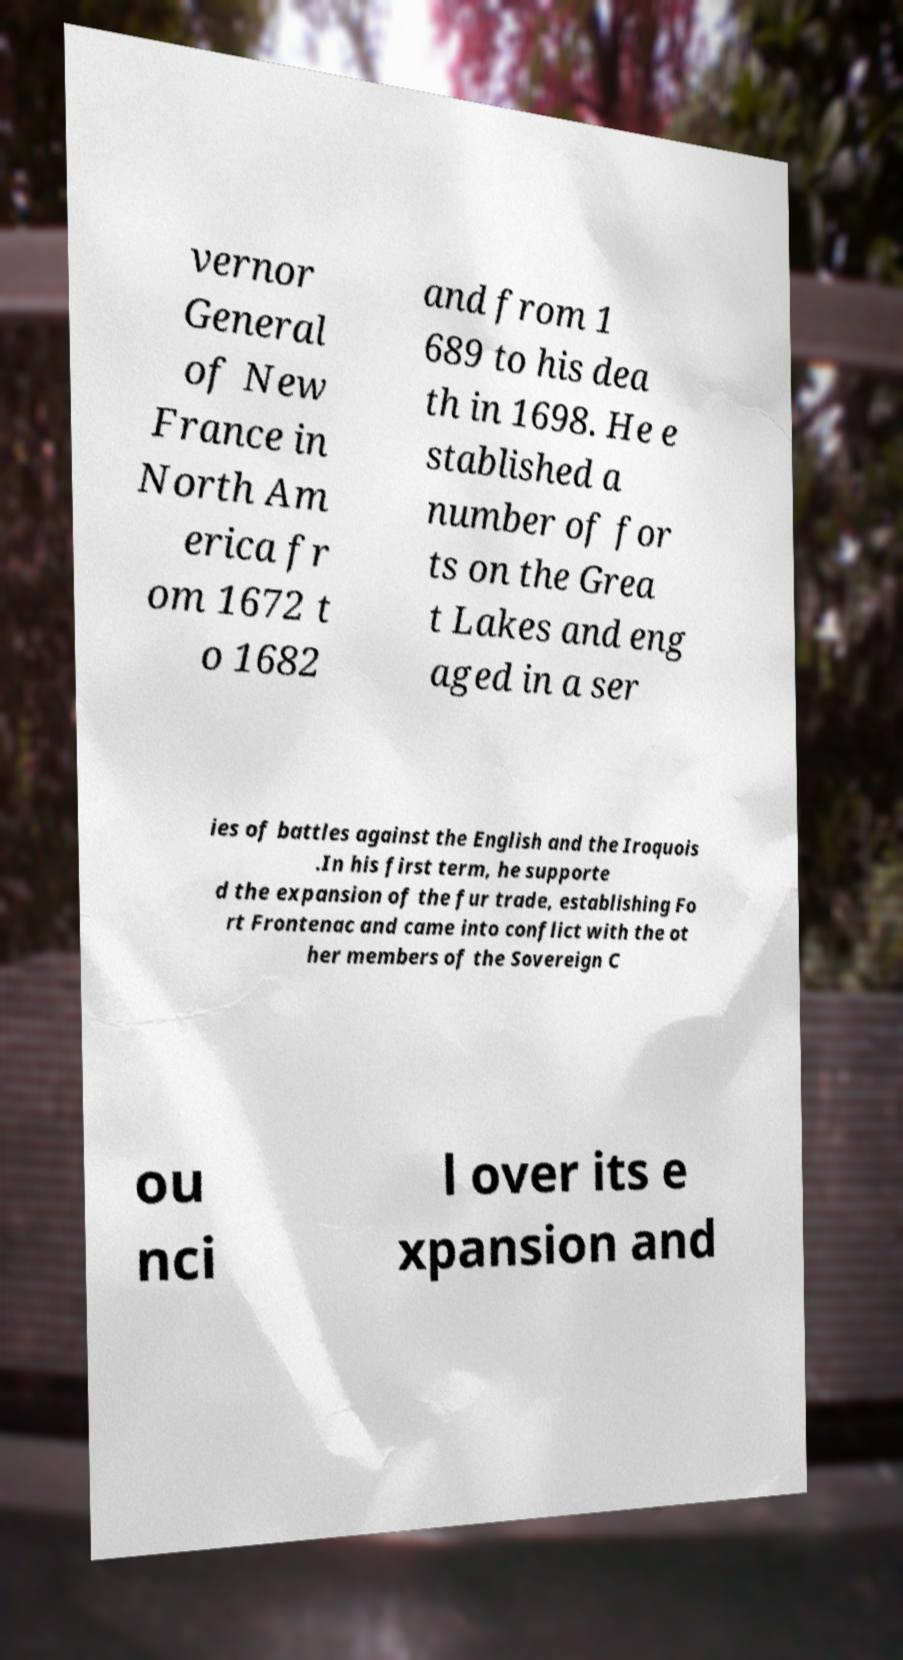I need the written content from this picture converted into text. Can you do that? vernor General of New France in North Am erica fr om 1672 t o 1682 and from 1 689 to his dea th in 1698. He e stablished a number of for ts on the Grea t Lakes and eng aged in a ser ies of battles against the English and the Iroquois .In his first term, he supporte d the expansion of the fur trade, establishing Fo rt Frontenac and came into conflict with the ot her members of the Sovereign C ou nci l over its e xpansion and 